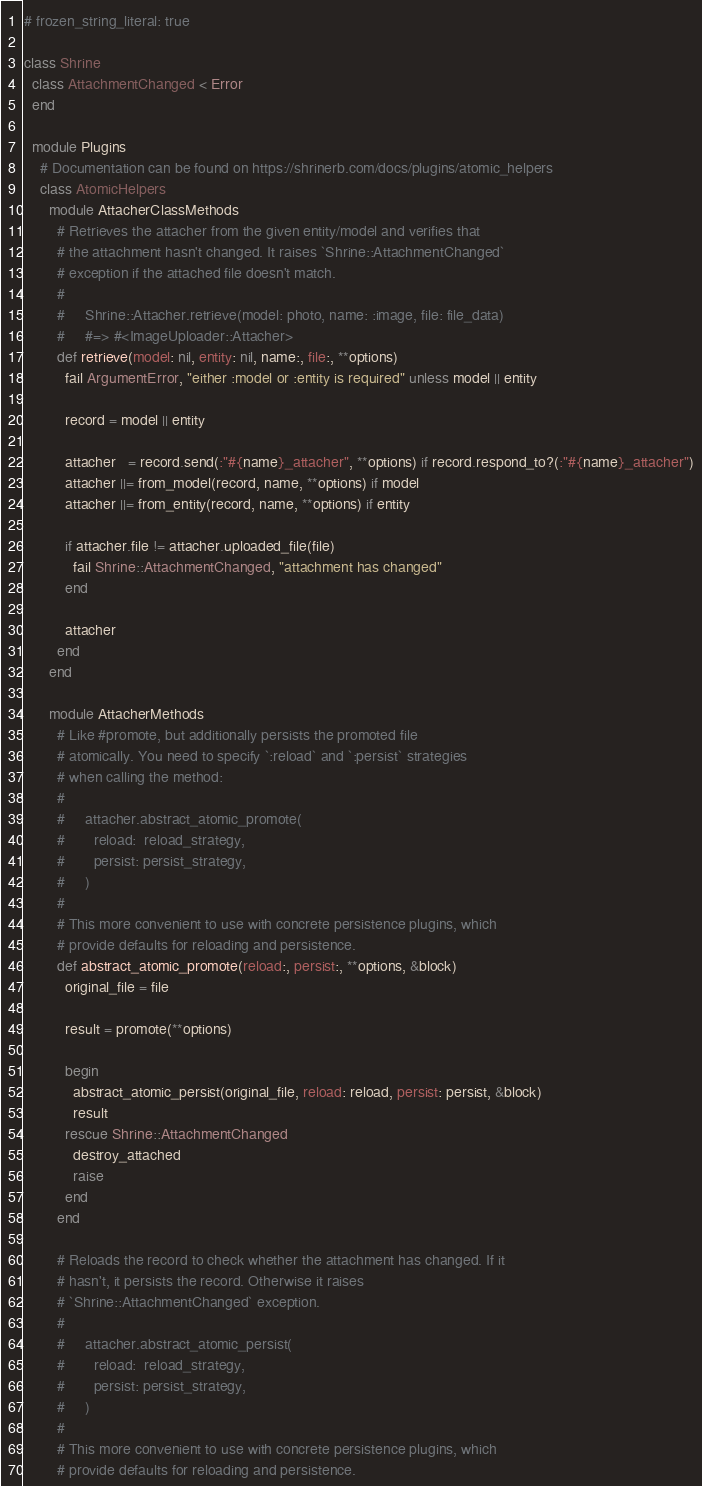Convert code to text. <code><loc_0><loc_0><loc_500><loc_500><_Ruby_># frozen_string_literal: true

class Shrine
  class AttachmentChanged < Error
  end

  module Plugins
    # Documentation can be found on https://shrinerb.com/docs/plugins/atomic_helpers
    class AtomicHelpers
      module AttacherClassMethods
        # Retrieves the attacher from the given entity/model and verifies that
        # the attachment hasn't changed. It raises `Shrine::AttachmentChanged`
        # exception if the attached file doesn't match.
        #
        #     Shrine::Attacher.retrieve(model: photo, name: :image, file: file_data)
        #     #=> #<ImageUploader::Attacher>
        def retrieve(model: nil, entity: nil, name:, file:, **options)
          fail ArgumentError, "either :model or :entity is required" unless model || entity

          record = model || entity

          attacher   = record.send(:"#{name}_attacher", **options) if record.respond_to?(:"#{name}_attacher")
          attacher ||= from_model(record, name, **options) if model
          attacher ||= from_entity(record, name, **options) if entity

          if attacher.file != attacher.uploaded_file(file)
            fail Shrine::AttachmentChanged, "attachment has changed"
          end

          attacher
        end
      end

      module AttacherMethods
        # Like #promote, but additionally persists the promoted file
        # atomically. You need to specify `:reload` and `:persist` strategies
        # when calling the method:
        #
        #     attacher.abstract_atomic_promote(
        #       reload:  reload_strategy,
        #       persist: persist_strategy,
        #     )
        #
        # This more convenient to use with concrete persistence plugins, which
        # provide defaults for reloading and persistence.
        def abstract_atomic_promote(reload:, persist:, **options, &block)
          original_file = file

          result = promote(**options)

          begin
            abstract_atomic_persist(original_file, reload: reload, persist: persist, &block)
            result
          rescue Shrine::AttachmentChanged
            destroy_attached
            raise
          end
        end

        # Reloads the record to check whether the attachment has changed. If it
        # hasn't, it persists the record. Otherwise it raises
        # `Shrine::AttachmentChanged` exception.
        #
        #     attacher.abstract_atomic_persist(
        #       reload:  reload_strategy,
        #       persist: persist_strategy,
        #     )
        #
        # This more convenient to use with concrete persistence plugins, which
        # provide defaults for reloading and persistence.</code> 